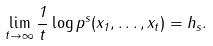<formula> <loc_0><loc_0><loc_500><loc_500>\lim _ { t \rightarrow \infty } \frac { 1 } { t } \log p ^ { s } ( x _ { 1 } , \dots , x _ { t } ) = h _ { s } .</formula> 